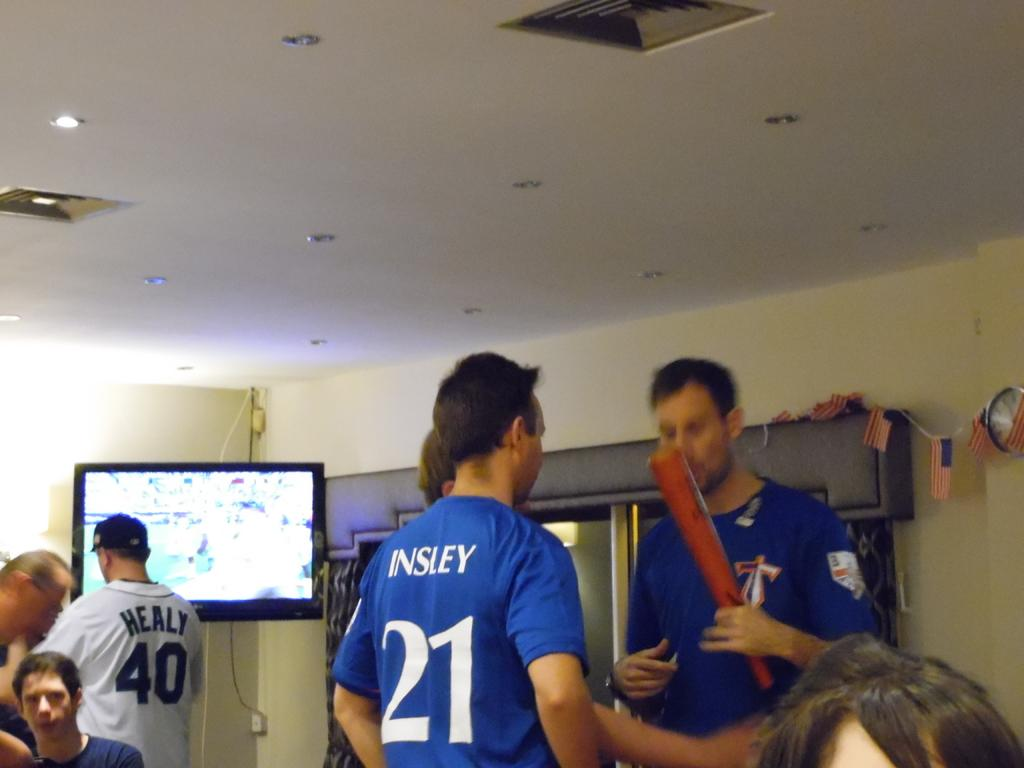<image>
Give a short and clear explanation of the subsequent image. A man in a blue jersey with the number 21 is talking with a group of people. 